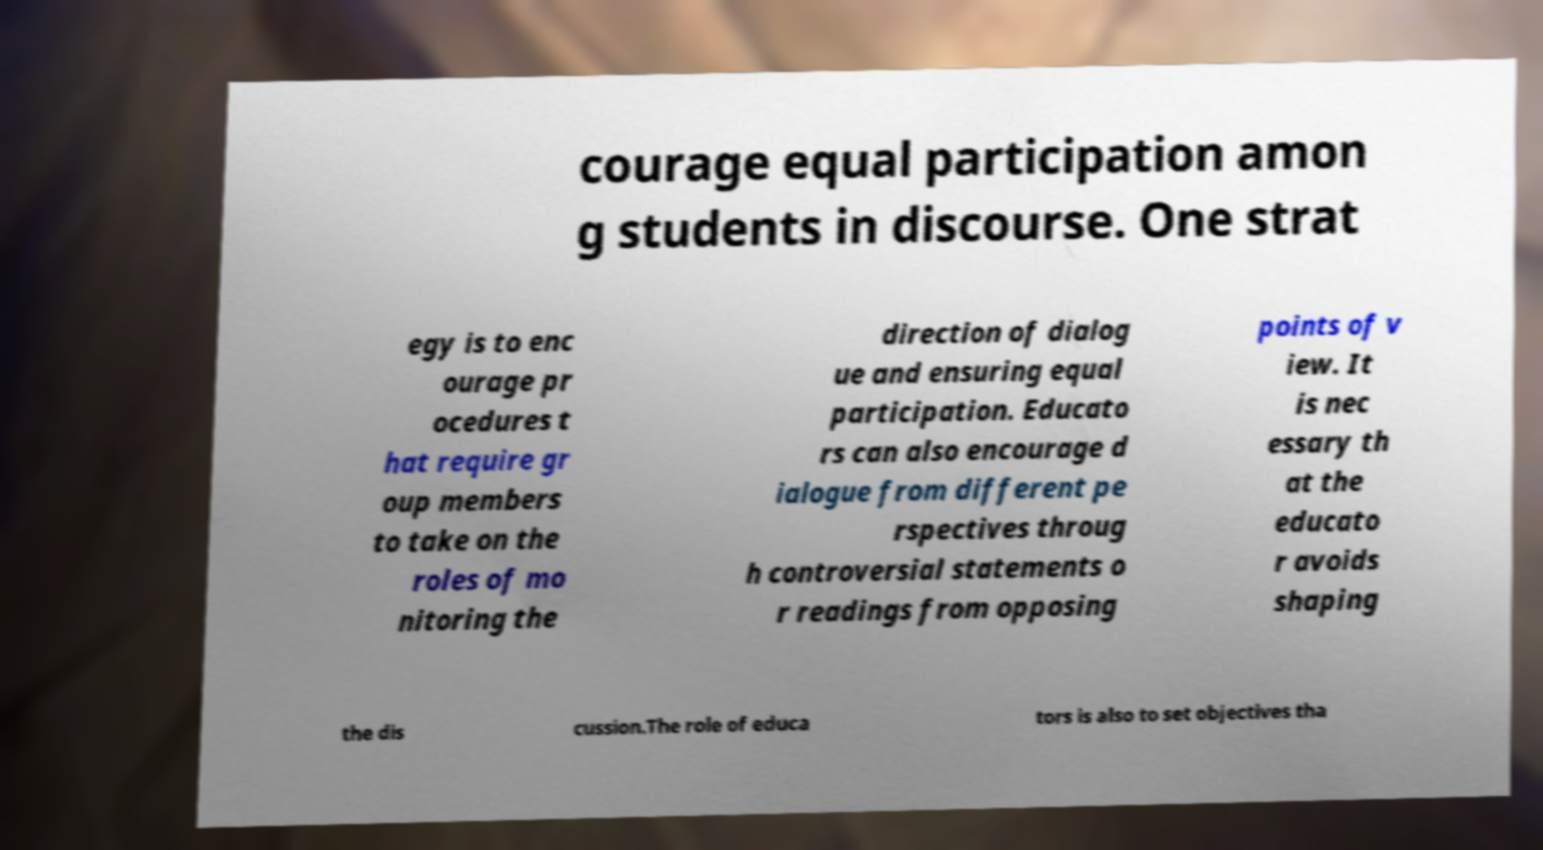Can you accurately transcribe the text from the provided image for me? courage equal participation amon g students in discourse. One strat egy is to enc ourage pr ocedures t hat require gr oup members to take on the roles of mo nitoring the direction of dialog ue and ensuring equal participation. Educato rs can also encourage d ialogue from different pe rspectives throug h controversial statements o r readings from opposing points of v iew. It is nec essary th at the educato r avoids shaping the dis cussion.The role of educa tors is also to set objectives tha 